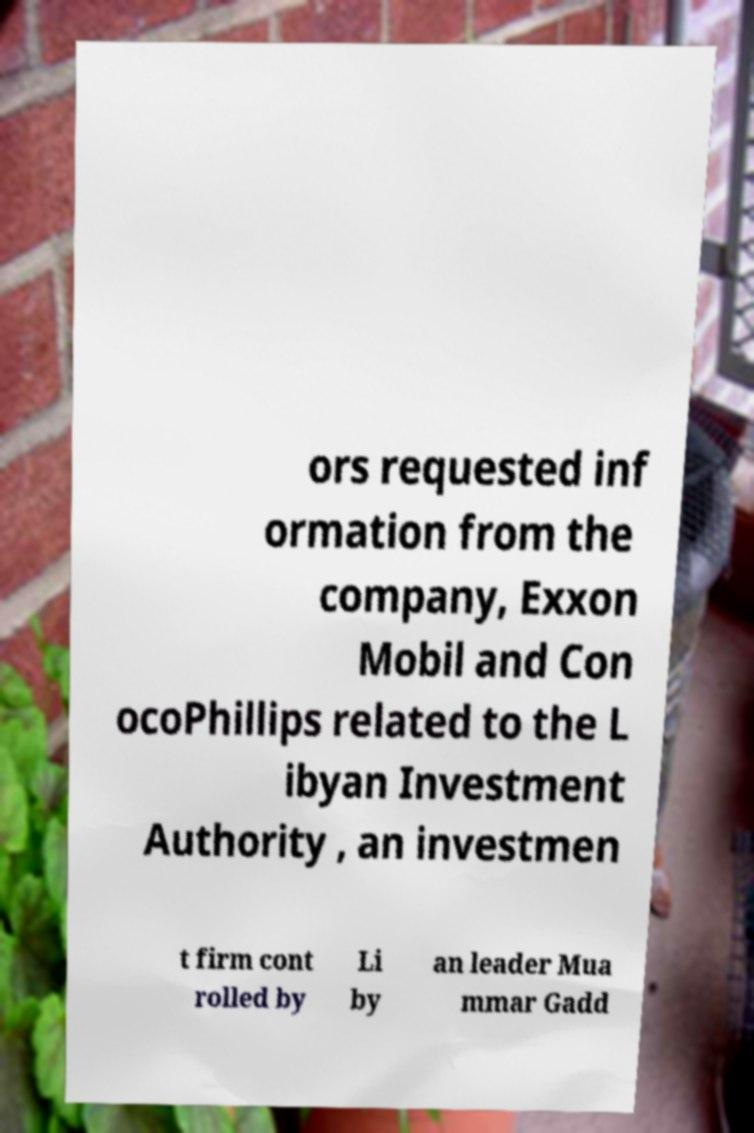Please identify and transcribe the text found in this image. ors requested inf ormation from the company, Exxon Mobil and Con ocoPhillips related to the L ibyan Investment Authority , an investmen t firm cont rolled by Li by an leader Mua mmar Gadd 